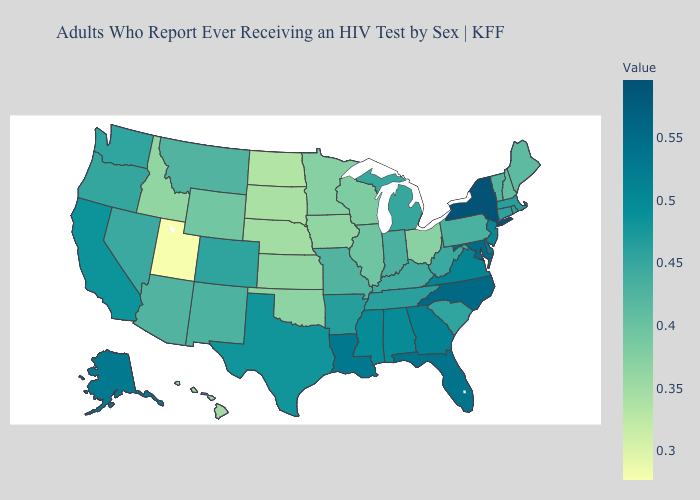Which states hav the highest value in the South?
Short answer required. North Carolina. Does Alaska have the highest value in the West?
Be succinct. Yes. Does the map have missing data?
Write a very short answer. No. Does Utah have the lowest value in the USA?
Be succinct. Yes. Among the states that border Illinois , does Kentucky have the lowest value?
Give a very brief answer. No. 